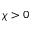Convert formula to latex. <formula><loc_0><loc_0><loc_500><loc_500>\chi > 0</formula> 